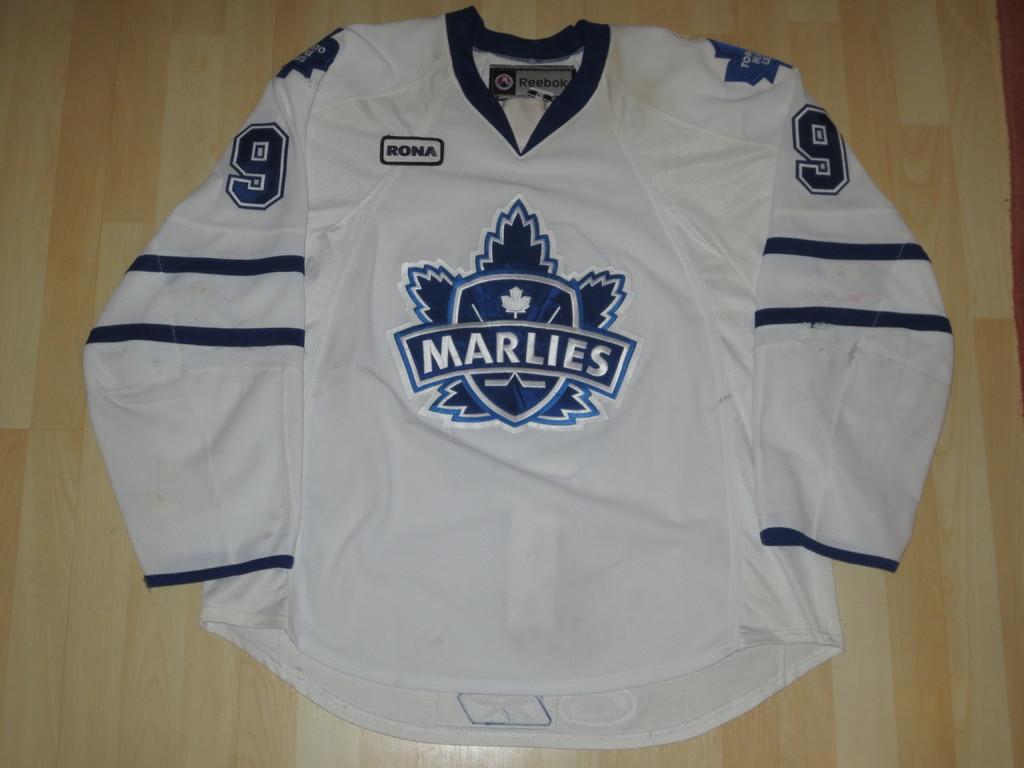What name is on the sport shirt?
Keep it short and to the point. Marlies. What number is shown on the jersey?
Offer a very short reply. 9. 